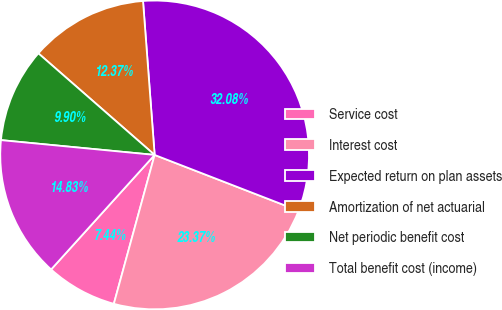Convert chart. <chart><loc_0><loc_0><loc_500><loc_500><pie_chart><fcel>Service cost<fcel>Interest cost<fcel>Expected return on plan assets<fcel>Amortization of net actuarial<fcel>Net periodic benefit cost<fcel>Total benefit cost (income)<nl><fcel>7.44%<fcel>23.37%<fcel>32.08%<fcel>12.37%<fcel>9.9%<fcel>14.83%<nl></chart> 